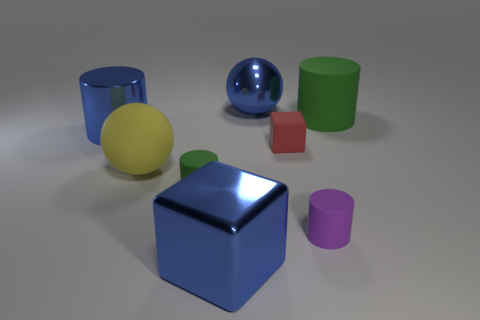Subtract all large green rubber cylinders. How many cylinders are left? 3 Add 1 large cyan matte spheres. How many objects exist? 9 Subtract all blue blocks. How many blocks are left? 1 Subtract 3 cylinders. How many cylinders are left? 1 Subtract all cyan cylinders. How many brown blocks are left? 0 Subtract all tiny purple matte objects. Subtract all rubber balls. How many objects are left? 6 Add 8 tiny purple cylinders. How many tiny purple cylinders are left? 9 Add 2 shiny cubes. How many shiny cubes exist? 3 Subtract 0 yellow cubes. How many objects are left? 8 Subtract all red blocks. Subtract all gray spheres. How many blocks are left? 1 